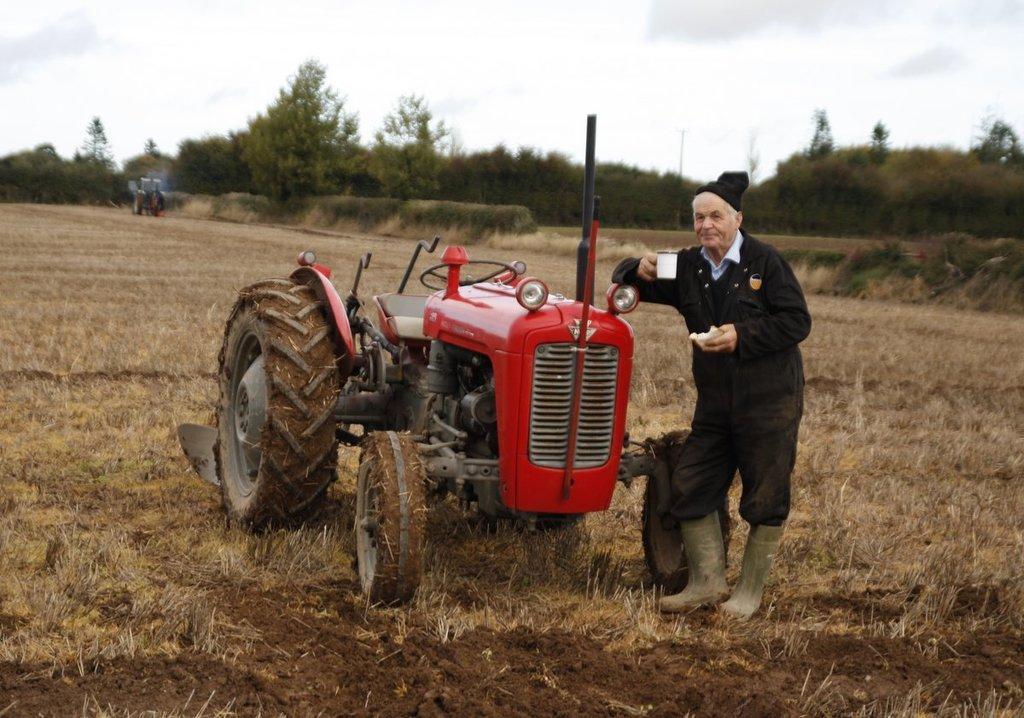Can you describe this image briefly? In the center of the image there is a tractor. On the right we can see a man standing and holding a cup in his hand. In the background there are trees, vehicle, grass and sky. 